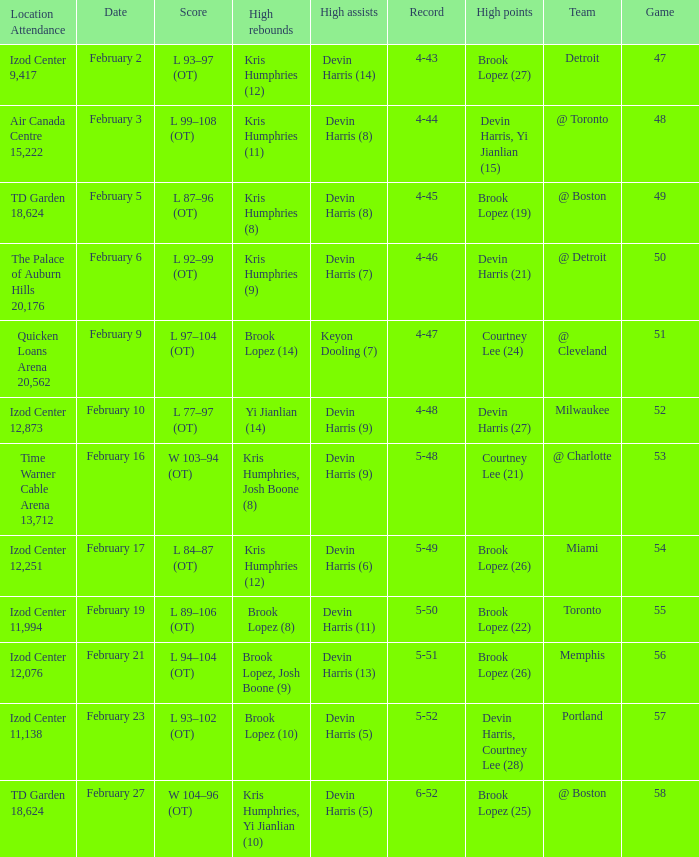Who did the high assists in the game played on February 9? Keyon Dooling (7). 